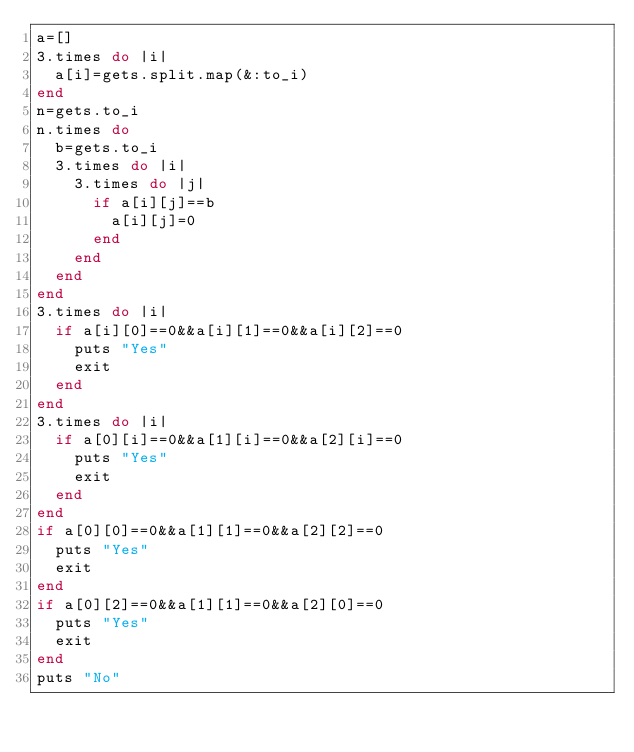<code> <loc_0><loc_0><loc_500><loc_500><_Ruby_>a=[]
3.times do |i|
  a[i]=gets.split.map(&:to_i)
end
n=gets.to_i
n.times do
  b=gets.to_i
  3.times do |i|
    3.times do |j|
      if a[i][j]==b
        a[i][j]=0
      end
    end
  end
end
3.times do |i|
  if a[i][0]==0&&a[i][1]==0&&a[i][2]==0
    puts "Yes"
    exit
  end
end
3.times do |i|
  if a[0][i]==0&&a[1][i]==0&&a[2][i]==0
    puts "Yes"
    exit
  end
end
if a[0][0]==0&&a[1][1]==0&&a[2][2]==0
  puts "Yes"
  exit
end
if a[0][2]==0&&a[1][1]==0&&a[2][0]==0
  puts "Yes"
  exit
end
puts "No"

</code> 